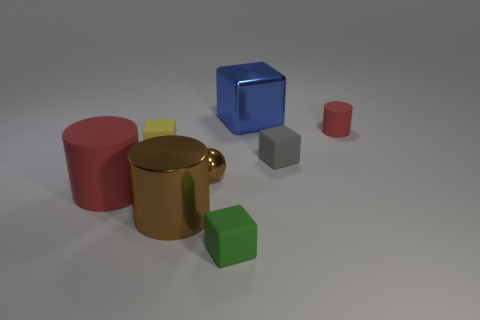Do the green cube and the yellow rubber block have the same size?
Your answer should be very brief. Yes. The metal thing behind the yellow cube has what shape?
Keep it short and to the point. Cube. Is there a yellow rubber ball that has the same size as the brown shiny cylinder?
Make the answer very short. No. What is the material of the brown object that is the same size as the blue shiny block?
Give a very brief answer. Metal. There is a matte cylinder that is in front of the tiny gray block; what is its size?
Make the answer very short. Large. What is the size of the brown cylinder?
Offer a terse response. Large. There is a gray matte block; does it have the same size as the red thing that is right of the big metallic cube?
Provide a succinct answer. Yes. There is a cylinder to the right of the big thing behind the brown metal ball; what color is it?
Ensure brevity in your answer.  Red. Is the number of metal blocks that are on the right side of the small red object the same as the number of large blue shiny blocks that are in front of the big blue metal cube?
Provide a short and direct response. Yes. Does the large cylinder that is behind the brown cylinder have the same material as the tiny yellow cube?
Your response must be concise. Yes. 